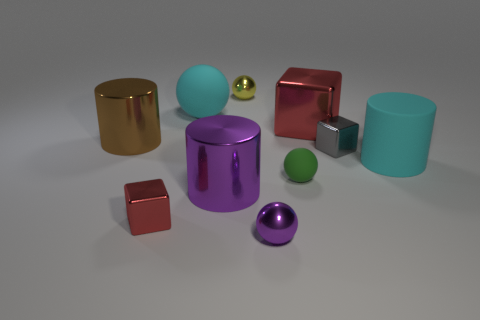Subtract all tiny purple metal spheres. How many spheres are left? 3 Subtract all yellow spheres. How many spheres are left? 3 Subtract all yellow cylinders. Subtract all red spheres. How many cylinders are left? 3 Subtract all cylinders. How many objects are left? 7 Subtract all tiny red blocks. Subtract all small shiny objects. How many objects are left? 5 Add 4 gray metal blocks. How many gray metal blocks are left? 5 Add 1 big blue shiny blocks. How many big blue shiny blocks exist? 1 Subtract 1 purple cylinders. How many objects are left? 9 